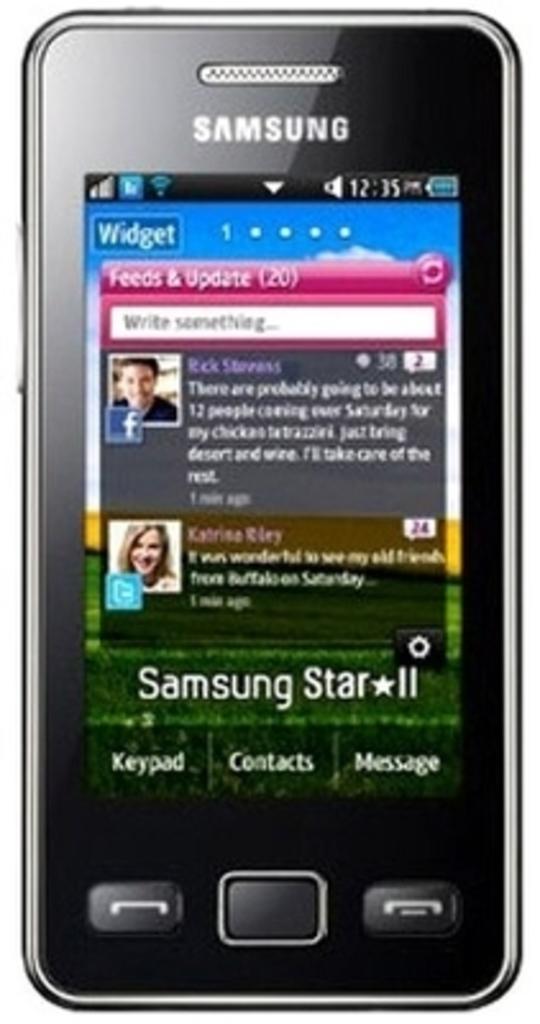What is the center option at the bottom of this app?
Ensure brevity in your answer.  Contacts. What brand is written on this phone at the top?
Your answer should be compact. Samsung. 